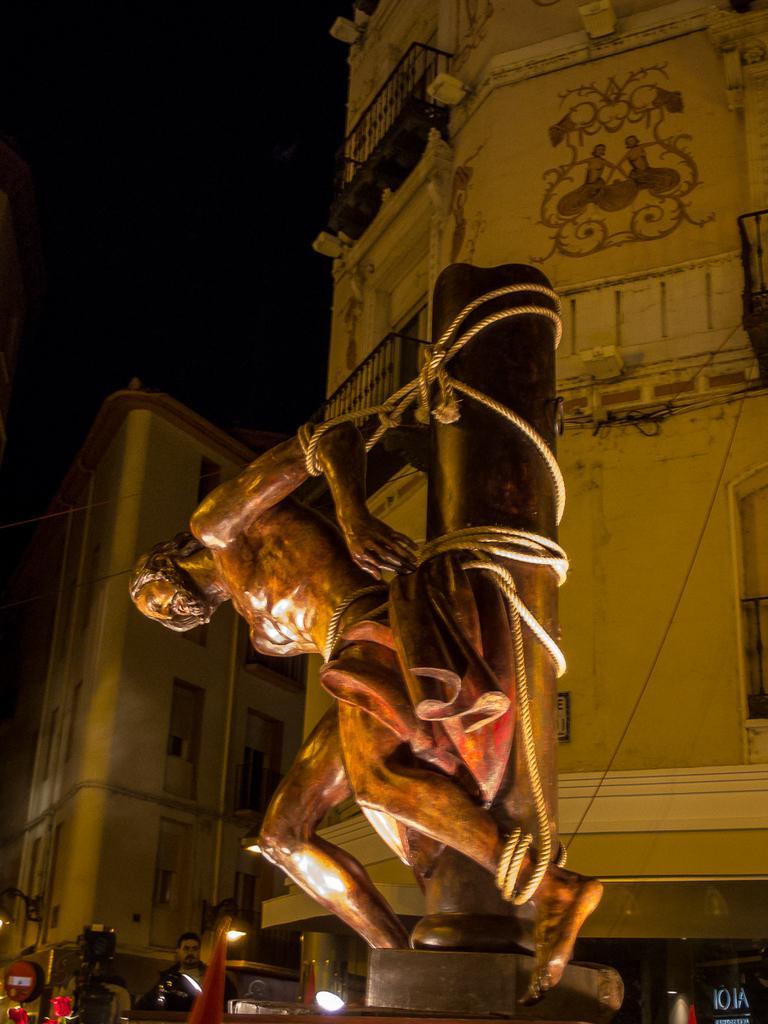How would you summarize this image in a sentence or two? In the image we can see there is a human statue tied with rope to the wooden pole. There is a person standing on the ground and behind there are buildings. The sky is dark. 